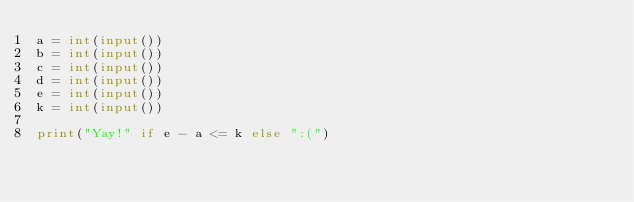Convert code to text. <code><loc_0><loc_0><loc_500><loc_500><_Python_>a = int(input())
b = int(input())
c = int(input())
d = int(input())
e = int(input())
k = int(input())

print("Yay!" if e - a <= k else ":(")</code> 